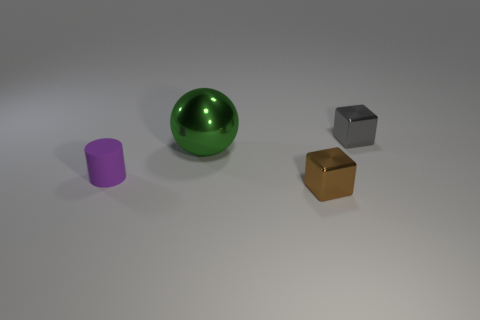What number of purple cylinders are right of the green shiny thing?
Ensure brevity in your answer.  0. Are there any purple things that have the same material as the cylinder?
Provide a succinct answer. No. Are there more green objects in front of the small rubber thing than brown shiny blocks that are right of the small brown metal object?
Provide a succinct answer. No. The cylinder is what size?
Ensure brevity in your answer.  Small. What is the shape of the tiny shiny object to the left of the tiny gray shiny block?
Your answer should be compact. Cube. Is the gray object the same shape as the large green shiny thing?
Ensure brevity in your answer.  No. Is the number of small purple things on the left side of the purple rubber thing the same as the number of big brown matte objects?
Ensure brevity in your answer.  Yes. What shape is the large green metal object?
Offer a very short reply. Sphere. Is there anything else of the same color as the cylinder?
Your answer should be very brief. No. Do the metal block that is in front of the small gray thing and the metallic thing left of the brown shiny block have the same size?
Make the answer very short. No. 